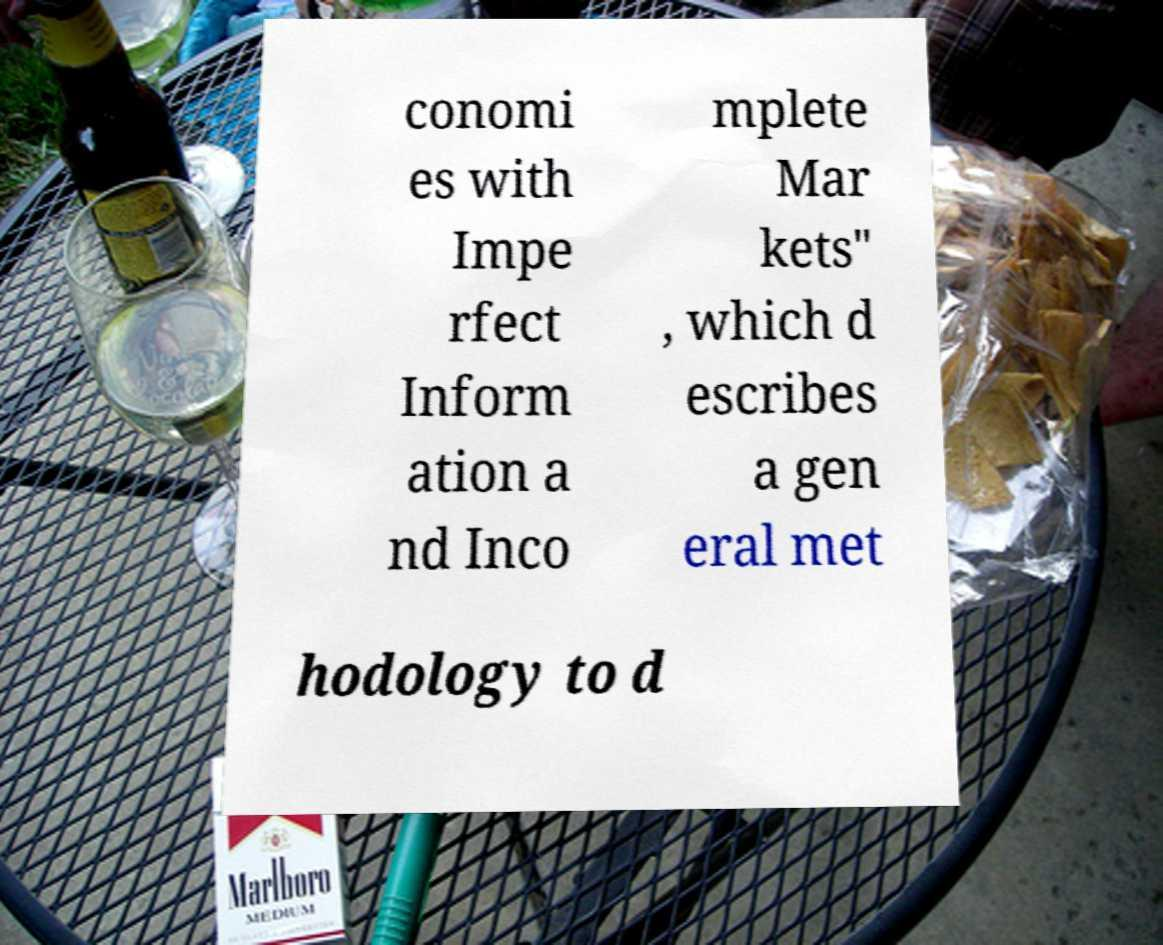I need the written content from this picture converted into text. Can you do that? conomi es with Impe rfect Inform ation a nd Inco mplete Mar kets" , which d escribes a gen eral met hodology to d 